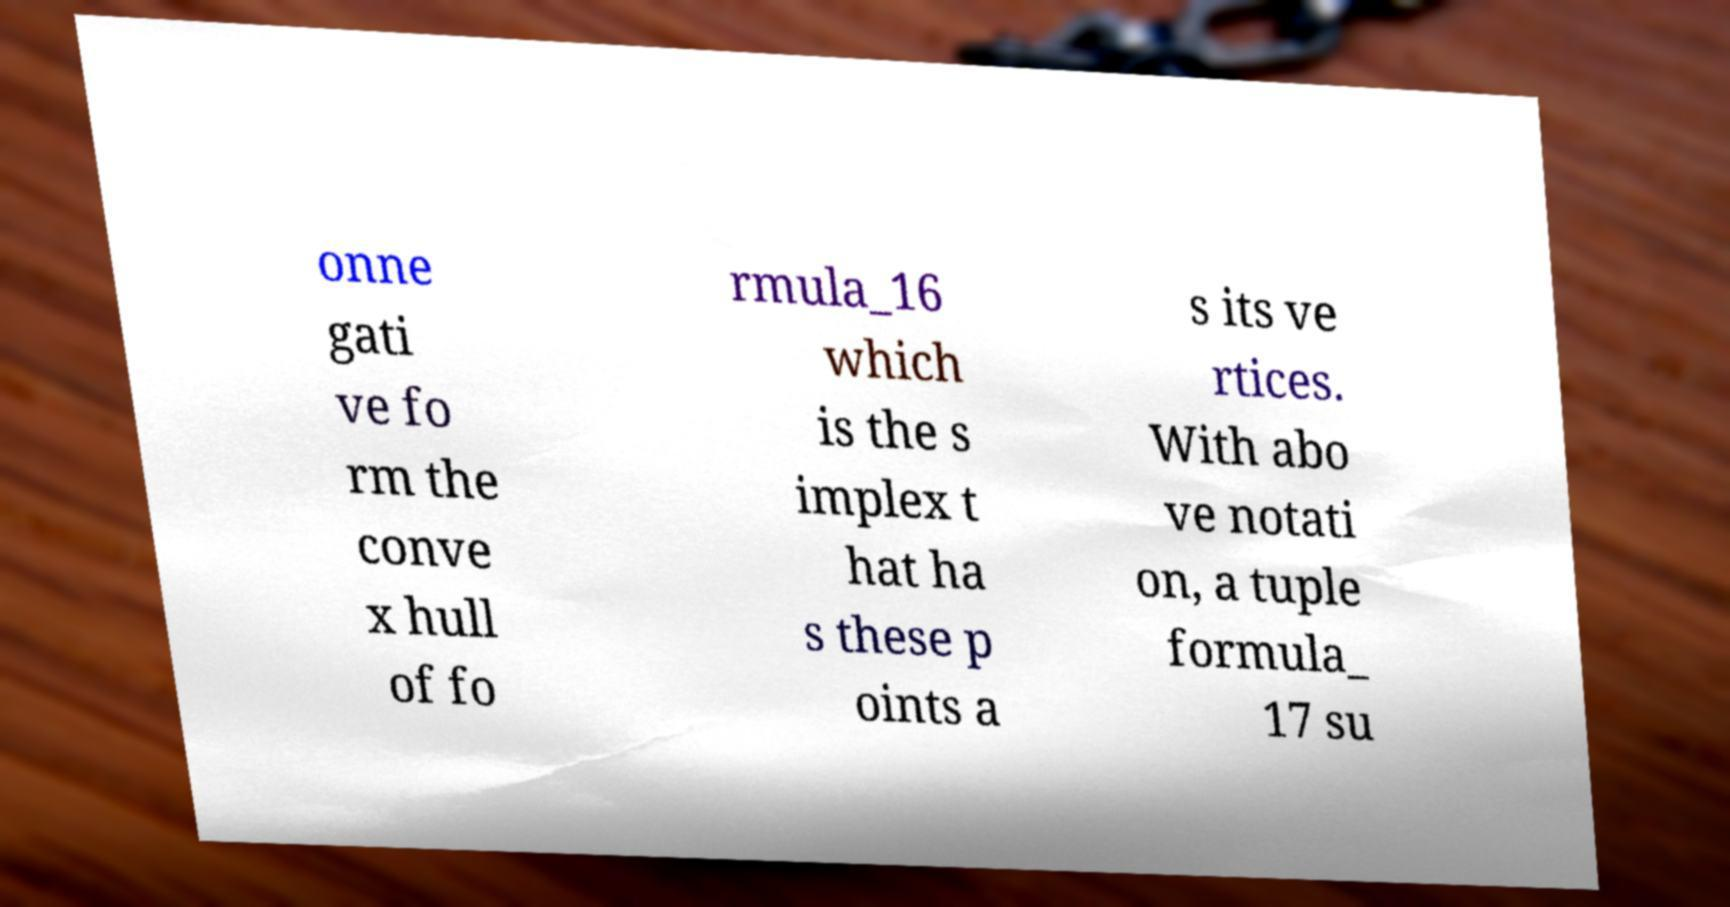I need the written content from this picture converted into text. Can you do that? onne gati ve fo rm the conve x hull of fo rmula_16 which is the s implex t hat ha s these p oints a s its ve rtices. With abo ve notati on, a tuple formula_ 17 su 